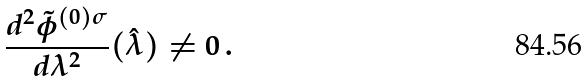<formula> <loc_0><loc_0><loc_500><loc_500>\frac { d ^ { 2 } \tilde { \phi } ^ { ( 0 ) \sigma } } { d \lambda ^ { 2 } } ( \hat { \lambda } ) \neq 0 \, .</formula> 